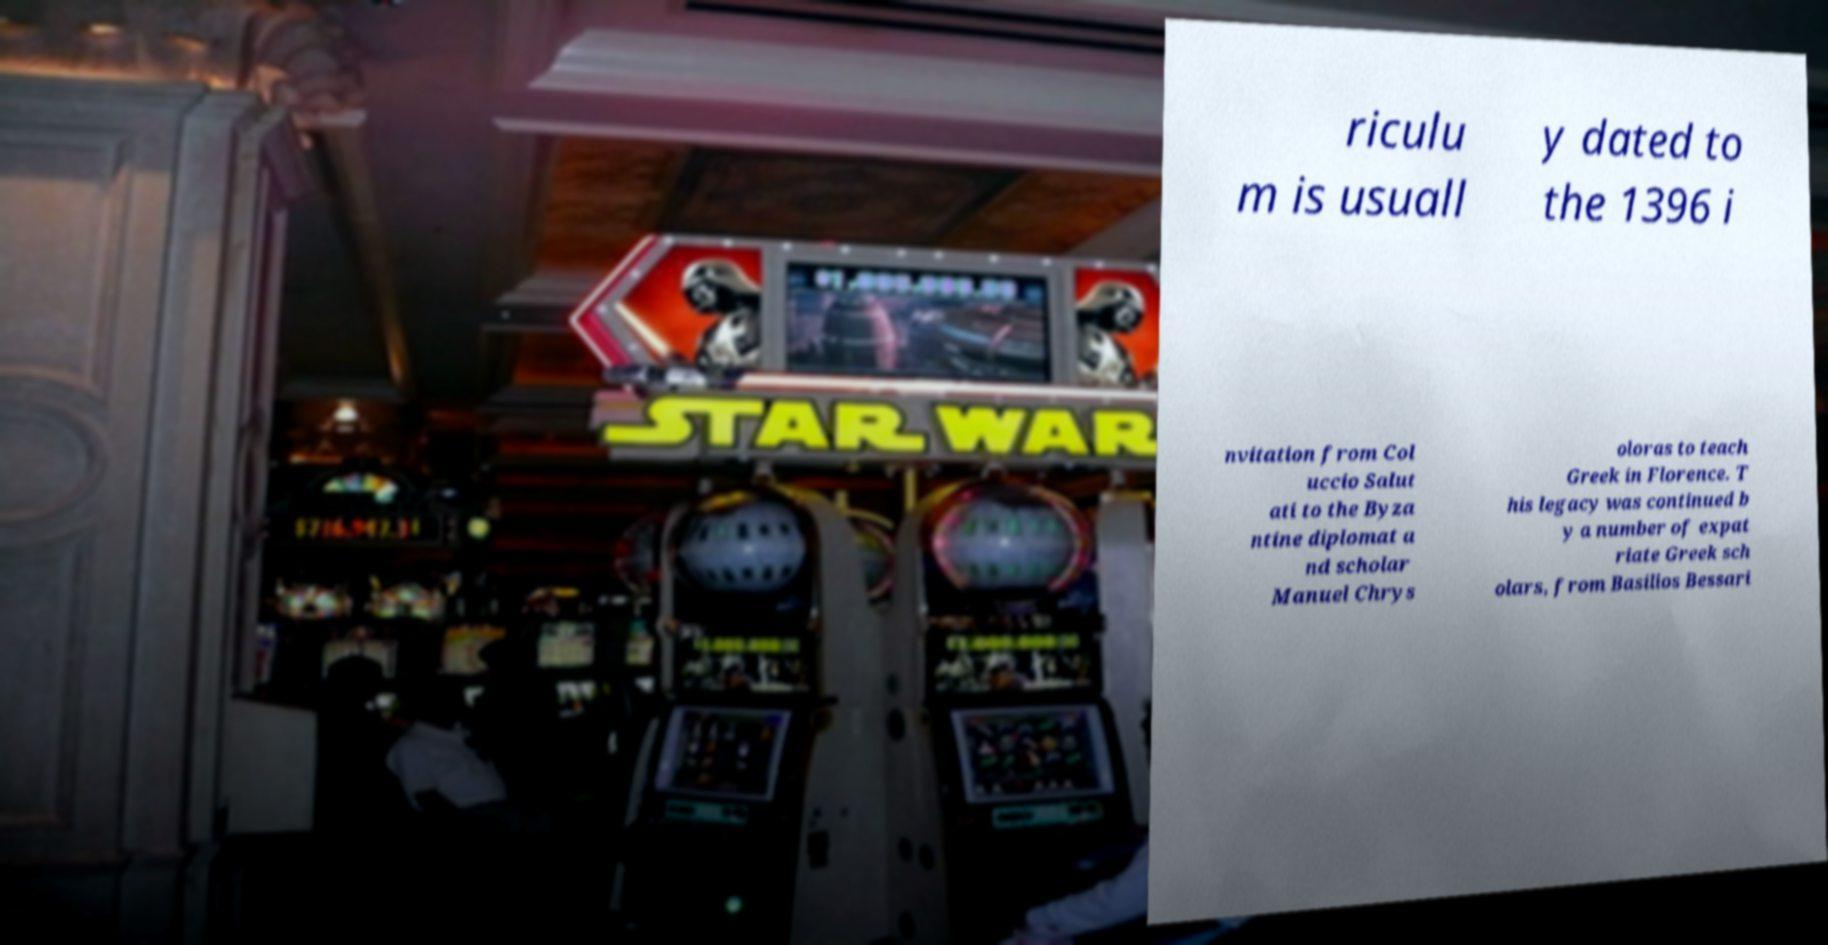Can you accurately transcribe the text from the provided image for me? riculu m is usuall y dated to the 1396 i nvitation from Col uccio Salut ati to the Byza ntine diplomat a nd scholar Manuel Chrys oloras to teach Greek in Florence. T his legacy was continued b y a number of expat riate Greek sch olars, from Basilios Bessari 